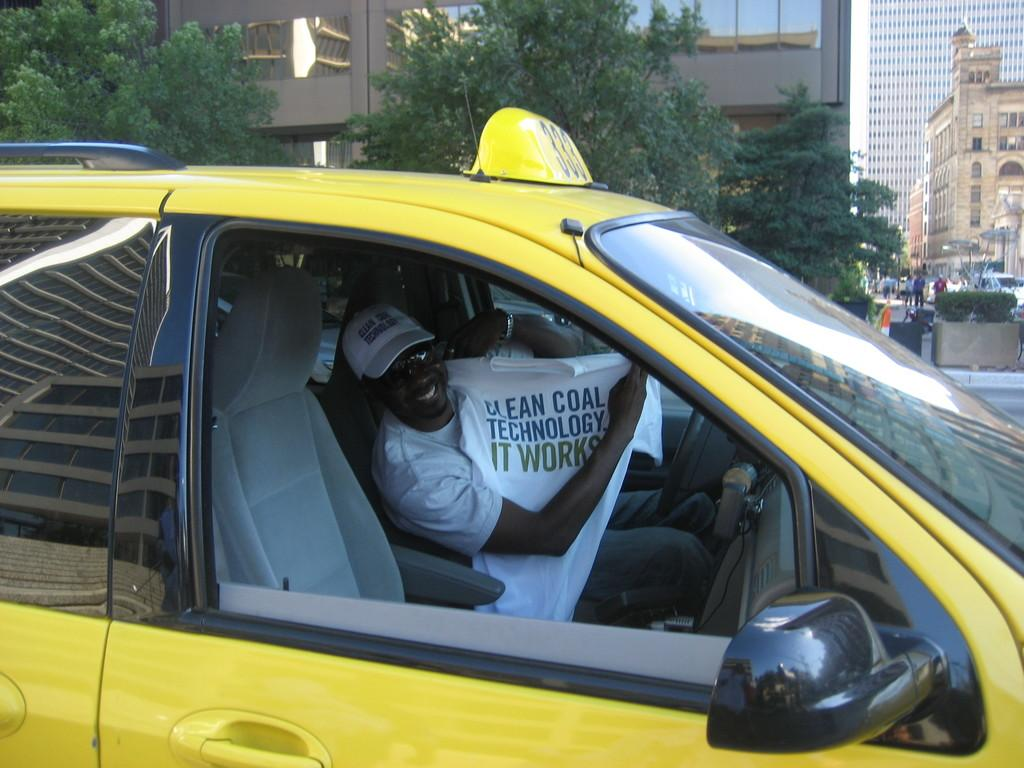<image>
Describe the image concisely. A taxi driver holds up a t-shirt that reads Clean Coal Technology. 